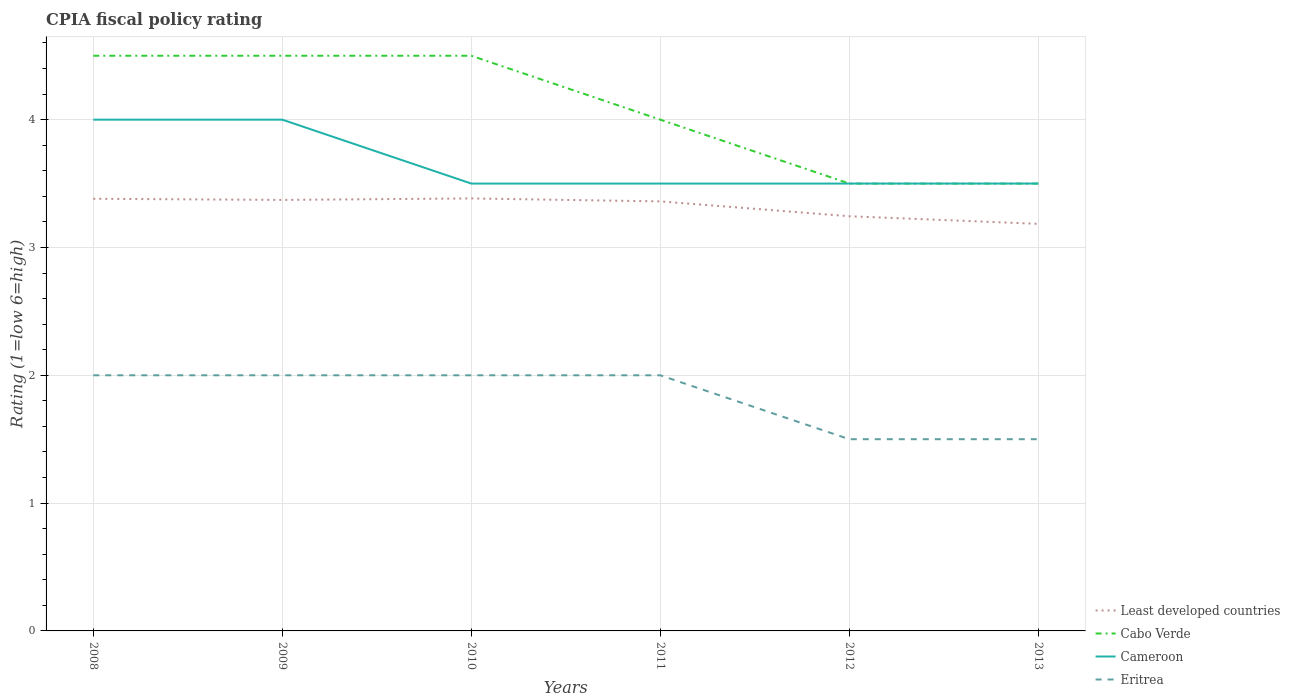In which year was the CPIA rating in Least developed countries maximum?
Provide a succinct answer. 2013. What is the difference between the highest and the second highest CPIA rating in Cameroon?
Provide a short and direct response. 0.5. How many lines are there?
Your response must be concise. 4. How many years are there in the graph?
Give a very brief answer. 6. What is the difference between two consecutive major ticks on the Y-axis?
Make the answer very short. 1. Are the values on the major ticks of Y-axis written in scientific E-notation?
Your answer should be compact. No. Does the graph contain any zero values?
Provide a succinct answer. No. Does the graph contain grids?
Give a very brief answer. Yes. Where does the legend appear in the graph?
Make the answer very short. Bottom right. How many legend labels are there?
Your response must be concise. 4. How are the legend labels stacked?
Your response must be concise. Vertical. What is the title of the graph?
Offer a very short reply. CPIA fiscal policy rating. What is the label or title of the X-axis?
Keep it short and to the point. Years. What is the label or title of the Y-axis?
Provide a short and direct response. Rating (1=low 6=high). What is the Rating (1=low 6=high) of Least developed countries in 2008?
Provide a succinct answer. 3.38. What is the Rating (1=low 6=high) in Eritrea in 2008?
Give a very brief answer. 2. What is the Rating (1=low 6=high) in Least developed countries in 2009?
Provide a succinct answer. 3.37. What is the Rating (1=low 6=high) in Cabo Verde in 2009?
Your response must be concise. 4.5. What is the Rating (1=low 6=high) of Least developed countries in 2010?
Your answer should be very brief. 3.38. What is the Rating (1=low 6=high) of Cameroon in 2010?
Give a very brief answer. 3.5. What is the Rating (1=low 6=high) in Least developed countries in 2011?
Offer a very short reply. 3.36. What is the Rating (1=low 6=high) of Cabo Verde in 2011?
Offer a terse response. 4. What is the Rating (1=low 6=high) of Eritrea in 2011?
Keep it short and to the point. 2. What is the Rating (1=low 6=high) of Least developed countries in 2012?
Ensure brevity in your answer.  3.24. What is the Rating (1=low 6=high) in Cameroon in 2012?
Your answer should be compact. 3.5. What is the Rating (1=low 6=high) in Eritrea in 2012?
Provide a succinct answer. 1.5. What is the Rating (1=low 6=high) in Least developed countries in 2013?
Offer a very short reply. 3.18. What is the Rating (1=low 6=high) of Cabo Verde in 2013?
Offer a terse response. 3.5. What is the Rating (1=low 6=high) of Eritrea in 2013?
Offer a very short reply. 1.5. Across all years, what is the maximum Rating (1=low 6=high) of Least developed countries?
Your answer should be very brief. 3.38. Across all years, what is the maximum Rating (1=low 6=high) of Cameroon?
Give a very brief answer. 4. Across all years, what is the maximum Rating (1=low 6=high) of Eritrea?
Ensure brevity in your answer.  2. Across all years, what is the minimum Rating (1=low 6=high) of Least developed countries?
Make the answer very short. 3.18. Across all years, what is the minimum Rating (1=low 6=high) of Eritrea?
Make the answer very short. 1.5. What is the total Rating (1=low 6=high) of Least developed countries in the graph?
Provide a succinct answer. 19.93. What is the total Rating (1=low 6=high) in Cameroon in the graph?
Your answer should be very brief. 22. What is the total Rating (1=low 6=high) in Eritrea in the graph?
Your response must be concise. 11. What is the difference between the Rating (1=low 6=high) of Least developed countries in 2008 and that in 2009?
Offer a terse response. 0.01. What is the difference between the Rating (1=low 6=high) in Cameroon in 2008 and that in 2009?
Keep it short and to the point. 0. What is the difference between the Rating (1=low 6=high) in Least developed countries in 2008 and that in 2010?
Keep it short and to the point. -0. What is the difference between the Rating (1=low 6=high) in Least developed countries in 2008 and that in 2011?
Give a very brief answer. 0.02. What is the difference between the Rating (1=low 6=high) in Cabo Verde in 2008 and that in 2011?
Keep it short and to the point. 0.5. What is the difference between the Rating (1=low 6=high) in Cameroon in 2008 and that in 2011?
Your answer should be very brief. 0.5. What is the difference between the Rating (1=low 6=high) in Eritrea in 2008 and that in 2011?
Your answer should be compact. 0. What is the difference between the Rating (1=low 6=high) of Least developed countries in 2008 and that in 2012?
Keep it short and to the point. 0.14. What is the difference between the Rating (1=low 6=high) of Cabo Verde in 2008 and that in 2012?
Offer a terse response. 1. What is the difference between the Rating (1=low 6=high) of Least developed countries in 2008 and that in 2013?
Your answer should be compact. 0.2. What is the difference between the Rating (1=low 6=high) of Cameroon in 2008 and that in 2013?
Your response must be concise. 0.5. What is the difference between the Rating (1=low 6=high) in Least developed countries in 2009 and that in 2010?
Your response must be concise. -0.01. What is the difference between the Rating (1=low 6=high) in Eritrea in 2009 and that in 2010?
Your answer should be very brief. 0. What is the difference between the Rating (1=low 6=high) of Least developed countries in 2009 and that in 2011?
Give a very brief answer. 0.01. What is the difference between the Rating (1=low 6=high) of Least developed countries in 2009 and that in 2012?
Your response must be concise. 0.13. What is the difference between the Rating (1=low 6=high) of Cabo Verde in 2009 and that in 2012?
Your response must be concise. 1. What is the difference between the Rating (1=low 6=high) in Cameroon in 2009 and that in 2012?
Provide a short and direct response. 0.5. What is the difference between the Rating (1=low 6=high) of Eritrea in 2009 and that in 2012?
Offer a terse response. 0.5. What is the difference between the Rating (1=low 6=high) in Least developed countries in 2009 and that in 2013?
Your response must be concise. 0.19. What is the difference between the Rating (1=low 6=high) of Cabo Verde in 2009 and that in 2013?
Provide a short and direct response. 1. What is the difference between the Rating (1=low 6=high) in Cameroon in 2009 and that in 2013?
Provide a short and direct response. 0.5. What is the difference between the Rating (1=low 6=high) in Least developed countries in 2010 and that in 2011?
Provide a short and direct response. 0.02. What is the difference between the Rating (1=low 6=high) of Eritrea in 2010 and that in 2011?
Keep it short and to the point. 0. What is the difference between the Rating (1=low 6=high) of Least developed countries in 2010 and that in 2012?
Offer a very short reply. 0.14. What is the difference between the Rating (1=low 6=high) in Cabo Verde in 2010 and that in 2012?
Your answer should be compact. 1. What is the difference between the Rating (1=low 6=high) of Least developed countries in 2010 and that in 2013?
Provide a short and direct response. 0.2. What is the difference between the Rating (1=low 6=high) of Cabo Verde in 2010 and that in 2013?
Offer a very short reply. 1. What is the difference between the Rating (1=low 6=high) of Cameroon in 2010 and that in 2013?
Offer a terse response. 0. What is the difference between the Rating (1=low 6=high) in Least developed countries in 2011 and that in 2012?
Keep it short and to the point. 0.12. What is the difference between the Rating (1=low 6=high) of Cabo Verde in 2011 and that in 2012?
Offer a terse response. 0.5. What is the difference between the Rating (1=low 6=high) of Cameroon in 2011 and that in 2012?
Your answer should be very brief. 0. What is the difference between the Rating (1=low 6=high) in Eritrea in 2011 and that in 2012?
Provide a succinct answer. 0.5. What is the difference between the Rating (1=low 6=high) in Least developed countries in 2011 and that in 2013?
Offer a very short reply. 0.18. What is the difference between the Rating (1=low 6=high) in Cameroon in 2011 and that in 2013?
Ensure brevity in your answer.  0. What is the difference between the Rating (1=low 6=high) of Eritrea in 2011 and that in 2013?
Make the answer very short. 0.5. What is the difference between the Rating (1=low 6=high) in Least developed countries in 2012 and that in 2013?
Your response must be concise. 0.06. What is the difference between the Rating (1=low 6=high) of Cameroon in 2012 and that in 2013?
Make the answer very short. 0. What is the difference between the Rating (1=low 6=high) in Least developed countries in 2008 and the Rating (1=low 6=high) in Cabo Verde in 2009?
Your answer should be compact. -1.12. What is the difference between the Rating (1=low 6=high) in Least developed countries in 2008 and the Rating (1=low 6=high) in Cameroon in 2009?
Offer a very short reply. -0.62. What is the difference between the Rating (1=low 6=high) in Least developed countries in 2008 and the Rating (1=low 6=high) in Eritrea in 2009?
Offer a terse response. 1.38. What is the difference between the Rating (1=low 6=high) in Cabo Verde in 2008 and the Rating (1=low 6=high) in Eritrea in 2009?
Your answer should be very brief. 2.5. What is the difference between the Rating (1=low 6=high) of Cameroon in 2008 and the Rating (1=low 6=high) of Eritrea in 2009?
Your answer should be very brief. 2. What is the difference between the Rating (1=low 6=high) in Least developed countries in 2008 and the Rating (1=low 6=high) in Cabo Verde in 2010?
Your response must be concise. -1.12. What is the difference between the Rating (1=low 6=high) of Least developed countries in 2008 and the Rating (1=low 6=high) of Cameroon in 2010?
Offer a very short reply. -0.12. What is the difference between the Rating (1=low 6=high) in Least developed countries in 2008 and the Rating (1=low 6=high) in Eritrea in 2010?
Make the answer very short. 1.38. What is the difference between the Rating (1=low 6=high) in Cabo Verde in 2008 and the Rating (1=low 6=high) in Cameroon in 2010?
Offer a terse response. 1. What is the difference between the Rating (1=low 6=high) in Cabo Verde in 2008 and the Rating (1=low 6=high) in Eritrea in 2010?
Offer a very short reply. 2.5. What is the difference between the Rating (1=low 6=high) of Cameroon in 2008 and the Rating (1=low 6=high) of Eritrea in 2010?
Offer a very short reply. 2. What is the difference between the Rating (1=low 6=high) in Least developed countries in 2008 and the Rating (1=low 6=high) in Cabo Verde in 2011?
Offer a very short reply. -0.62. What is the difference between the Rating (1=low 6=high) in Least developed countries in 2008 and the Rating (1=low 6=high) in Cameroon in 2011?
Your answer should be compact. -0.12. What is the difference between the Rating (1=low 6=high) of Least developed countries in 2008 and the Rating (1=low 6=high) of Eritrea in 2011?
Provide a short and direct response. 1.38. What is the difference between the Rating (1=low 6=high) in Cabo Verde in 2008 and the Rating (1=low 6=high) in Cameroon in 2011?
Offer a very short reply. 1. What is the difference between the Rating (1=low 6=high) of Cabo Verde in 2008 and the Rating (1=low 6=high) of Eritrea in 2011?
Your response must be concise. 2.5. What is the difference between the Rating (1=low 6=high) in Least developed countries in 2008 and the Rating (1=low 6=high) in Cabo Verde in 2012?
Offer a terse response. -0.12. What is the difference between the Rating (1=low 6=high) of Least developed countries in 2008 and the Rating (1=low 6=high) of Cameroon in 2012?
Your response must be concise. -0.12. What is the difference between the Rating (1=low 6=high) in Least developed countries in 2008 and the Rating (1=low 6=high) in Eritrea in 2012?
Make the answer very short. 1.88. What is the difference between the Rating (1=low 6=high) of Cabo Verde in 2008 and the Rating (1=low 6=high) of Cameroon in 2012?
Offer a very short reply. 1. What is the difference between the Rating (1=low 6=high) in Cabo Verde in 2008 and the Rating (1=low 6=high) in Eritrea in 2012?
Offer a very short reply. 3. What is the difference between the Rating (1=low 6=high) of Cameroon in 2008 and the Rating (1=low 6=high) of Eritrea in 2012?
Offer a terse response. 2.5. What is the difference between the Rating (1=low 6=high) in Least developed countries in 2008 and the Rating (1=low 6=high) in Cabo Verde in 2013?
Your answer should be very brief. -0.12. What is the difference between the Rating (1=low 6=high) in Least developed countries in 2008 and the Rating (1=low 6=high) in Cameroon in 2013?
Give a very brief answer. -0.12. What is the difference between the Rating (1=low 6=high) of Least developed countries in 2008 and the Rating (1=low 6=high) of Eritrea in 2013?
Your response must be concise. 1.88. What is the difference between the Rating (1=low 6=high) in Cabo Verde in 2008 and the Rating (1=low 6=high) in Cameroon in 2013?
Keep it short and to the point. 1. What is the difference between the Rating (1=low 6=high) of Cameroon in 2008 and the Rating (1=low 6=high) of Eritrea in 2013?
Provide a succinct answer. 2.5. What is the difference between the Rating (1=low 6=high) of Least developed countries in 2009 and the Rating (1=low 6=high) of Cabo Verde in 2010?
Offer a terse response. -1.13. What is the difference between the Rating (1=low 6=high) in Least developed countries in 2009 and the Rating (1=low 6=high) in Cameroon in 2010?
Keep it short and to the point. -0.13. What is the difference between the Rating (1=low 6=high) of Least developed countries in 2009 and the Rating (1=low 6=high) of Eritrea in 2010?
Offer a terse response. 1.37. What is the difference between the Rating (1=low 6=high) in Cabo Verde in 2009 and the Rating (1=low 6=high) in Eritrea in 2010?
Provide a short and direct response. 2.5. What is the difference between the Rating (1=low 6=high) in Least developed countries in 2009 and the Rating (1=low 6=high) in Cabo Verde in 2011?
Offer a terse response. -0.63. What is the difference between the Rating (1=low 6=high) in Least developed countries in 2009 and the Rating (1=low 6=high) in Cameroon in 2011?
Your response must be concise. -0.13. What is the difference between the Rating (1=low 6=high) in Least developed countries in 2009 and the Rating (1=low 6=high) in Eritrea in 2011?
Provide a short and direct response. 1.37. What is the difference between the Rating (1=low 6=high) of Cabo Verde in 2009 and the Rating (1=low 6=high) of Cameroon in 2011?
Make the answer very short. 1. What is the difference between the Rating (1=low 6=high) of Cabo Verde in 2009 and the Rating (1=low 6=high) of Eritrea in 2011?
Provide a succinct answer. 2.5. What is the difference between the Rating (1=low 6=high) of Cameroon in 2009 and the Rating (1=low 6=high) of Eritrea in 2011?
Provide a succinct answer. 2. What is the difference between the Rating (1=low 6=high) in Least developed countries in 2009 and the Rating (1=low 6=high) in Cabo Verde in 2012?
Ensure brevity in your answer.  -0.13. What is the difference between the Rating (1=low 6=high) in Least developed countries in 2009 and the Rating (1=low 6=high) in Cameroon in 2012?
Offer a very short reply. -0.13. What is the difference between the Rating (1=low 6=high) of Least developed countries in 2009 and the Rating (1=low 6=high) of Eritrea in 2012?
Your response must be concise. 1.87. What is the difference between the Rating (1=low 6=high) in Least developed countries in 2009 and the Rating (1=low 6=high) in Cabo Verde in 2013?
Provide a short and direct response. -0.13. What is the difference between the Rating (1=low 6=high) of Least developed countries in 2009 and the Rating (1=low 6=high) of Cameroon in 2013?
Provide a succinct answer. -0.13. What is the difference between the Rating (1=low 6=high) in Least developed countries in 2009 and the Rating (1=low 6=high) in Eritrea in 2013?
Make the answer very short. 1.87. What is the difference between the Rating (1=low 6=high) in Cabo Verde in 2009 and the Rating (1=low 6=high) in Eritrea in 2013?
Offer a very short reply. 3. What is the difference between the Rating (1=low 6=high) of Cameroon in 2009 and the Rating (1=low 6=high) of Eritrea in 2013?
Provide a short and direct response. 2.5. What is the difference between the Rating (1=low 6=high) in Least developed countries in 2010 and the Rating (1=low 6=high) in Cabo Verde in 2011?
Offer a terse response. -0.62. What is the difference between the Rating (1=low 6=high) in Least developed countries in 2010 and the Rating (1=low 6=high) in Cameroon in 2011?
Your response must be concise. -0.12. What is the difference between the Rating (1=low 6=high) of Least developed countries in 2010 and the Rating (1=low 6=high) of Eritrea in 2011?
Your answer should be very brief. 1.38. What is the difference between the Rating (1=low 6=high) in Cabo Verde in 2010 and the Rating (1=low 6=high) in Cameroon in 2011?
Your answer should be very brief. 1. What is the difference between the Rating (1=low 6=high) in Cabo Verde in 2010 and the Rating (1=low 6=high) in Eritrea in 2011?
Offer a very short reply. 2.5. What is the difference between the Rating (1=low 6=high) of Least developed countries in 2010 and the Rating (1=low 6=high) of Cabo Verde in 2012?
Your answer should be very brief. -0.12. What is the difference between the Rating (1=low 6=high) in Least developed countries in 2010 and the Rating (1=low 6=high) in Cameroon in 2012?
Keep it short and to the point. -0.12. What is the difference between the Rating (1=low 6=high) in Least developed countries in 2010 and the Rating (1=low 6=high) in Eritrea in 2012?
Your response must be concise. 1.88. What is the difference between the Rating (1=low 6=high) of Least developed countries in 2010 and the Rating (1=low 6=high) of Cabo Verde in 2013?
Ensure brevity in your answer.  -0.12. What is the difference between the Rating (1=low 6=high) in Least developed countries in 2010 and the Rating (1=low 6=high) in Cameroon in 2013?
Your response must be concise. -0.12. What is the difference between the Rating (1=low 6=high) in Least developed countries in 2010 and the Rating (1=low 6=high) in Eritrea in 2013?
Provide a succinct answer. 1.88. What is the difference between the Rating (1=low 6=high) of Least developed countries in 2011 and the Rating (1=low 6=high) of Cabo Verde in 2012?
Offer a very short reply. -0.14. What is the difference between the Rating (1=low 6=high) of Least developed countries in 2011 and the Rating (1=low 6=high) of Cameroon in 2012?
Offer a very short reply. -0.14. What is the difference between the Rating (1=low 6=high) in Least developed countries in 2011 and the Rating (1=low 6=high) in Eritrea in 2012?
Keep it short and to the point. 1.86. What is the difference between the Rating (1=low 6=high) of Least developed countries in 2011 and the Rating (1=low 6=high) of Cabo Verde in 2013?
Your response must be concise. -0.14. What is the difference between the Rating (1=low 6=high) in Least developed countries in 2011 and the Rating (1=low 6=high) in Cameroon in 2013?
Provide a succinct answer. -0.14. What is the difference between the Rating (1=low 6=high) in Least developed countries in 2011 and the Rating (1=low 6=high) in Eritrea in 2013?
Make the answer very short. 1.86. What is the difference between the Rating (1=low 6=high) in Cabo Verde in 2011 and the Rating (1=low 6=high) in Cameroon in 2013?
Offer a very short reply. 0.5. What is the difference between the Rating (1=low 6=high) of Cabo Verde in 2011 and the Rating (1=low 6=high) of Eritrea in 2013?
Offer a very short reply. 2.5. What is the difference between the Rating (1=low 6=high) of Cameroon in 2011 and the Rating (1=low 6=high) of Eritrea in 2013?
Offer a very short reply. 2. What is the difference between the Rating (1=low 6=high) of Least developed countries in 2012 and the Rating (1=low 6=high) of Cabo Verde in 2013?
Your answer should be very brief. -0.26. What is the difference between the Rating (1=low 6=high) in Least developed countries in 2012 and the Rating (1=low 6=high) in Cameroon in 2013?
Keep it short and to the point. -0.26. What is the difference between the Rating (1=low 6=high) in Least developed countries in 2012 and the Rating (1=low 6=high) in Eritrea in 2013?
Give a very brief answer. 1.74. What is the difference between the Rating (1=low 6=high) of Cabo Verde in 2012 and the Rating (1=low 6=high) of Cameroon in 2013?
Your response must be concise. 0. What is the average Rating (1=low 6=high) in Least developed countries per year?
Offer a very short reply. 3.32. What is the average Rating (1=low 6=high) of Cabo Verde per year?
Your response must be concise. 4.08. What is the average Rating (1=low 6=high) in Cameroon per year?
Your answer should be compact. 3.67. What is the average Rating (1=low 6=high) in Eritrea per year?
Give a very brief answer. 1.83. In the year 2008, what is the difference between the Rating (1=low 6=high) in Least developed countries and Rating (1=low 6=high) in Cabo Verde?
Make the answer very short. -1.12. In the year 2008, what is the difference between the Rating (1=low 6=high) in Least developed countries and Rating (1=low 6=high) in Cameroon?
Ensure brevity in your answer.  -0.62. In the year 2008, what is the difference between the Rating (1=low 6=high) of Least developed countries and Rating (1=low 6=high) of Eritrea?
Offer a terse response. 1.38. In the year 2008, what is the difference between the Rating (1=low 6=high) of Cameroon and Rating (1=low 6=high) of Eritrea?
Your answer should be compact. 2. In the year 2009, what is the difference between the Rating (1=low 6=high) of Least developed countries and Rating (1=low 6=high) of Cabo Verde?
Give a very brief answer. -1.13. In the year 2009, what is the difference between the Rating (1=low 6=high) of Least developed countries and Rating (1=low 6=high) of Cameroon?
Keep it short and to the point. -0.63. In the year 2009, what is the difference between the Rating (1=low 6=high) of Least developed countries and Rating (1=low 6=high) of Eritrea?
Make the answer very short. 1.37. In the year 2009, what is the difference between the Rating (1=low 6=high) in Cabo Verde and Rating (1=low 6=high) in Cameroon?
Give a very brief answer. 0.5. In the year 2009, what is the difference between the Rating (1=low 6=high) of Cabo Verde and Rating (1=low 6=high) of Eritrea?
Offer a terse response. 2.5. In the year 2009, what is the difference between the Rating (1=low 6=high) of Cameroon and Rating (1=low 6=high) of Eritrea?
Your answer should be compact. 2. In the year 2010, what is the difference between the Rating (1=low 6=high) of Least developed countries and Rating (1=low 6=high) of Cabo Verde?
Ensure brevity in your answer.  -1.12. In the year 2010, what is the difference between the Rating (1=low 6=high) of Least developed countries and Rating (1=low 6=high) of Cameroon?
Your answer should be compact. -0.12. In the year 2010, what is the difference between the Rating (1=low 6=high) in Least developed countries and Rating (1=low 6=high) in Eritrea?
Keep it short and to the point. 1.38. In the year 2010, what is the difference between the Rating (1=low 6=high) of Cabo Verde and Rating (1=low 6=high) of Cameroon?
Ensure brevity in your answer.  1. In the year 2010, what is the difference between the Rating (1=low 6=high) in Cabo Verde and Rating (1=low 6=high) in Eritrea?
Give a very brief answer. 2.5. In the year 2010, what is the difference between the Rating (1=low 6=high) of Cameroon and Rating (1=low 6=high) of Eritrea?
Offer a terse response. 1.5. In the year 2011, what is the difference between the Rating (1=low 6=high) of Least developed countries and Rating (1=low 6=high) of Cabo Verde?
Offer a terse response. -0.64. In the year 2011, what is the difference between the Rating (1=low 6=high) of Least developed countries and Rating (1=low 6=high) of Cameroon?
Offer a very short reply. -0.14. In the year 2011, what is the difference between the Rating (1=low 6=high) in Least developed countries and Rating (1=low 6=high) in Eritrea?
Your answer should be compact. 1.36. In the year 2012, what is the difference between the Rating (1=low 6=high) in Least developed countries and Rating (1=low 6=high) in Cabo Verde?
Offer a terse response. -0.26. In the year 2012, what is the difference between the Rating (1=low 6=high) in Least developed countries and Rating (1=low 6=high) in Cameroon?
Your response must be concise. -0.26. In the year 2012, what is the difference between the Rating (1=low 6=high) of Least developed countries and Rating (1=low 6=high) of Eritrea?
Ensure brevity in your answer.  1.74. In the year 2012, what is the difference between the Rating (1=low 6=high) of Cabo Verde and Rating (1=low 6=high) of Cameroon?
Ensure brevity in your answer.  0. In the year 2012, what is the difference between the Rating (1=low 6=high) of Cameroon and Rating (1=low 6=high) of Eritrea?
Make the answer very short. 2. In the year 2013, what is the difference between the Rating (1=low 6=high) of Least developed countries and Rating (1=low 6=high) of Cabo Verde?
Give a very brief answer. -0.32. In the year 2013, what is the difference between the Rating (1=low 6=high) of Least developed countries and Rating (1=low 6=high) of Cameroon?
Keep it short and to the point. -0.32. In the year 2013, what is the difference between the Rating (1=low 6=high) of Least developed countries and Rating (1=low 6=high) of Eritrea?
Your answer should be very brief. 1.68. In the year 2013, what is the difference between the Rating (1=low 6=high) of Cabo Verde and Rating (1=low 6=high) of Eritrea?
Offer a very short reply. 2. In the year 2013, what is the difference between the Rating (1=low 6=high) of Cameroon and Rating (1=low 6=high) of Eritrea?
Ensure brevity in your answer.  2. What is the ratio of the Rating (1=low 6=high) of Cabo Verde in 2008 to that in 2009?
Keep it short and to the point. 1. What is the ratio of the Rating (1=low 6=high) of Cameroon in 2008 to that in 2009?
Your response must be concise. 1. What is the ratio of the Rating (1=low 6=high) in Cabo Verde in 2008 to that in 2010?
Make the answer very short. 1. What is the ratio of the Rating (1=low 6=high) in Cameroon in 2008 to that in 2010?
Keep it short and to the point. 1.14. What is the ratio of the Rating (1=low 6=high) in Eritrea in 2008 to that in 2010?
Provide a short and direct response. 1. What is the ratio of the Rating (1=low 6=high) of Least developed countries in 2008 to that in 2011?
Your answer should be very brief. 1.01. What is the ratio of the Rating (1=low 6=high) in Cabo Verde in 2008 to that in 2011?
Keep it short and to the point. 1.12. What is the ratio of the Rating (1=low 6=high) of Least developed countries in 2008 to that in 2012?
Ensure brevity in your answer.  1.04. What is the ratio of the Rating (1=low 6=high) of Cabo Verde in 2008 to that in 2012?
Offer a terse response. 1.29. What is the ratio of the Rating (1=low 6=high) of Least developed countries in 2008 to that in 2013?
Provide a succinct answer. 1.06. What is the ratio of the Rating (1=low 6=high) in Cameroon in 2008 to that in 2013?
Your answer should be very brief. 1.14. What is the ratio of the Rating (1=low 6=high) of Least developed countries in 2009 to that in 2010?
Your answer should be very brief. 1. What is the ratio of the Rating (1=low 6=high) in Least developed countries in 2009 to that in 2011?
Keep it short and to the point. 1. What is the ratio of the Rating (1=low 6=high) in Cameroon in 2009 to that in 2011?
Make the answer very short. 1.14. What is the ratio of the Rating (1=low 6=high) in Least developed countries in 2009 to that in 2012?
Provide a short and direct response. 1.04. What is the ratio of the Rating (1=low 6=high) in Cameroon in 2009 to that in 2012?
Your answer should be very brief. 1.14. What is the ratio of the Rating (1=low 6=high) of Least developed countries in 2009 to that in 2013?
Make the answer very short. 1.06. What is the ratio of the Rating (1=low 6=high) in Cabo Verde in 2009 to that in 2013?
Provide a short and direct response. 1.29. What is the ratio of the Rating (1=low 6=high) of Cameroon in 2009 to that in 2013?
Keep it short and to the point. 1.14. What is the ratio of the Rating (1=low 6=high) in Cameroon in 2010 to that in 2011?
Your answer should be very brief. 1. What is the ratio of the Rating (1=low 6=high) of Eritrea in 2010 to that in 2011?
Your answer should be very brief. 1. What is the ratio of the Rating (1=low 6=high) of Least developed countries in 2010 to that in 2012?
Your answer should be very brief. 1.04. What is the ratio of the Rating (1=low 6=high) of Eritrea in 2010 to that in 2012?
Give a very brief answer. 1.33. What is the ratio of the Rating (1=low 6=high) in Least developed countries in 2010 to that in 2013?
Your response must be concise. 1.06. What is the ratio of the Rating (1=low 6=high) in Cabo Verde in 2010 to that in 2013?
Give a very brief answer. 1.29. What is the ratio of the Rating (1=low 6=high) in Cameroon in 2010 to that in 2013?
Your answer should be very brief. 1. What is the ratio of the Rating (1=low 6=high) of Eritrea in 2010 to that in 2013?
Offer a very short reply. 1.33. What is the ratio of the Rating (1=low 6=high) of Least developed countries in 2011 to that in 2012?
Your answer should be compact. 1.04. What is the ratio of the Rating (1=low 6=high) in Least developed countries in 2011 to that in 2013?
Offer a very short reply. 1.06. What is the ratio of the Rating (1=low 6=high) of Cameroon in 2011 to that in 2013?
Offer a terse response. 1. What is the ratio of the Rating (1=low 6=high) of Least developed countries in 2012 to that in 2013?
Ensure brevity in your answer.  1.02. What is the ratio of the Rating (1=low 6=high) in Cameroon in 2012 to that in 2013?
Keep it short and to the point. 1. What is the ratio of the Rating (1=low 6=high) of Eritrea in 2012 to that in 2013?
Provide a succinct answer. 1. What is the difference between the highest and the second highest Rating (1=low 6=high) of Least developed countries?
Keep it short and to the point. 0. What is the difference between the highest and the lowest Rating (1=low 6=high) of Least developed countries?
Ensure brevity in your answer.  0.2. What is the difference between the highest and the lowest Rating (1=low 6=high) of Cameroon?
Offer a terse response. 0.5. 